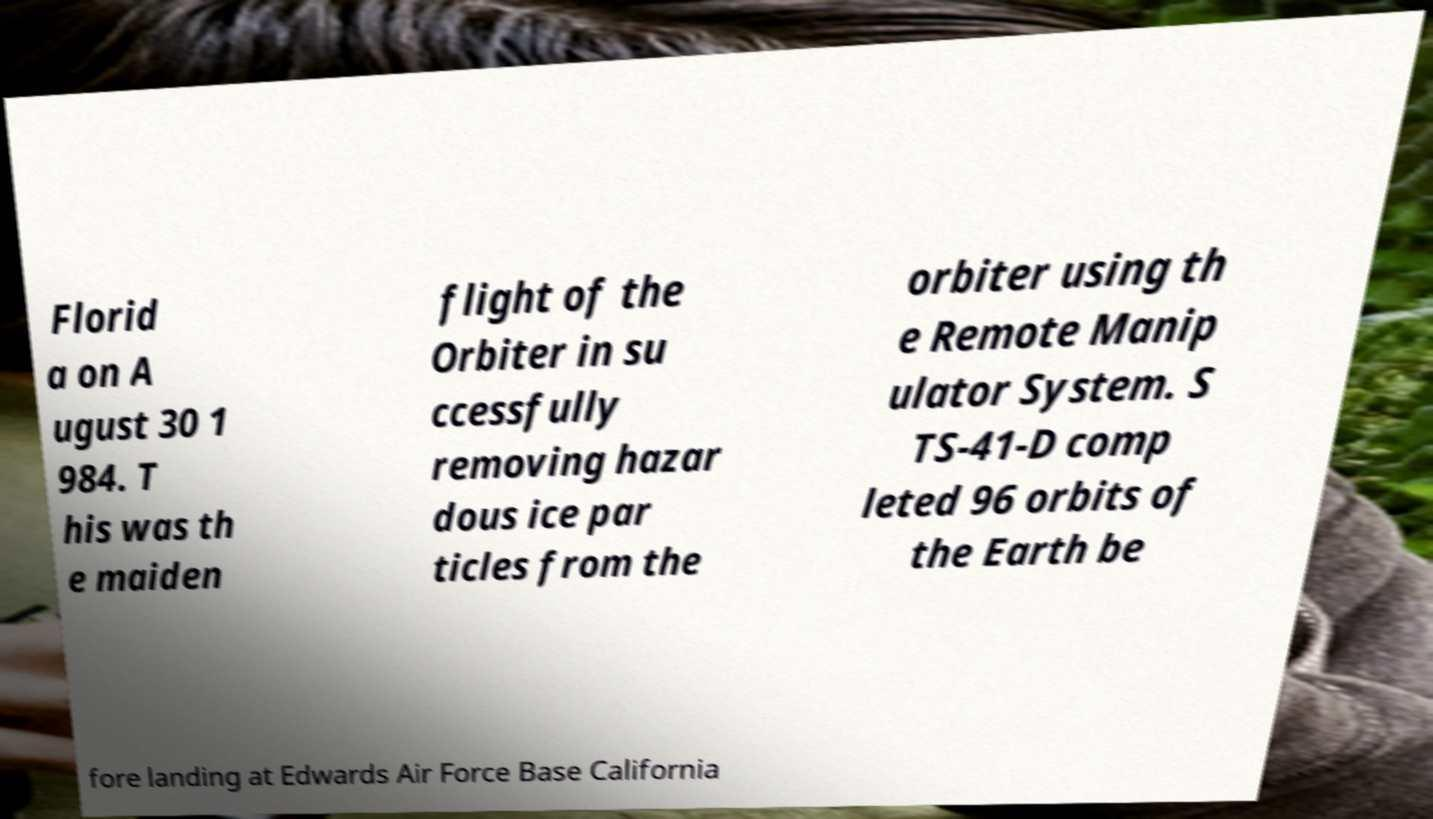What messages or text are displayed in this image? I need them in a readable, typed format. Florid a on A ugust 30 1 984. T his was th e maiden flight of the Orbiter in su ccessfully removing hazar dous ice par ticles from the orbiter using th e Remote Manip ulator System. S TS-41-D comp leted 96 orbits of the Earth be fore landing at Edwards Air Force Base California 